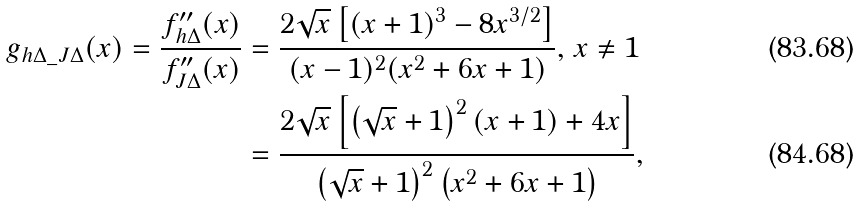<formula> <loc_0><loc_0><loc_500><loc_500>g _ { h \Delta \_ J \Delta } ( x ) = \frac { { f } ^ { \prime \prime } _ { h \Delta } ( x ) } { { f } ^ { \prime \prime } _ { J \Delta } ( x ) } & = \frac { 2 \sqrt { x } \left [ { ( x + 1 ) ^ { 3 } - 8 x ^ { 3 / 2 } } \right ] } { ( x - 1 ) ^ { 2 } ( x ^ { 2 } + 6 x + 1 ) } , \, x \ne 1 \\ & = \frac { 2 \sqrt { x } \left [ { \left ( { \sqrt { x } + 1 } \right ) ^ { 2 } ( x + 1 ) + 4 x } \right ] } { \left ( { \sqrt { x } + 1 } \right ) ^ { 2 } \left ( { x ^ { 2 } + 6 x + 1 } \right ) } ,</formula> 